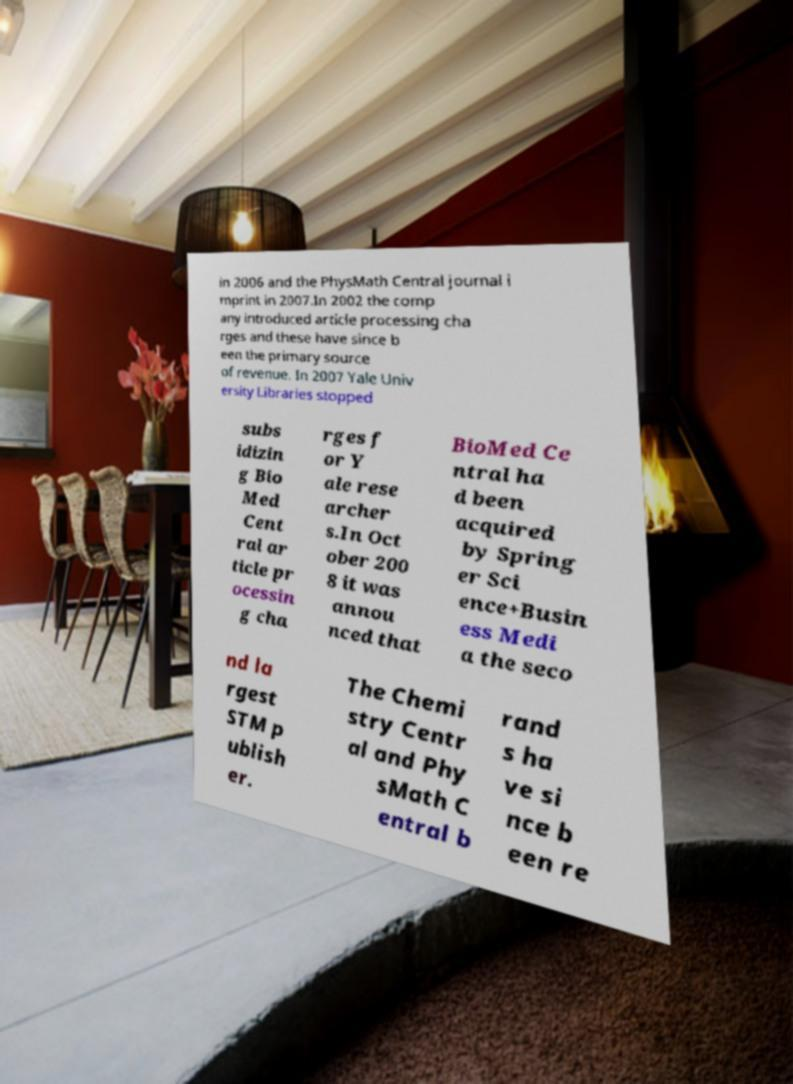Could you extract and type out the text from this image? in 2006 and the PhysMath Central journal i mprint in 2007.In 2002 the comp any introduced article processing cha rges and these have since b een the primary source of revenue. In 2007 Yale Univ ersity Libraries stopped subs idizin g Bio Med Cent ral ar ticle pr ocessin g cha rges f or Y ale rese archer s.In Oct ober 200 8 it was annou nced that BioMed Ce ntral ha d been acquired by Spring er Sci ence+Busin ess Medi a the seco nd la rgest STM p ublish er. The Chemi stry Centr al and Phy sMath C entral b rand s ha ve si nce b een re 